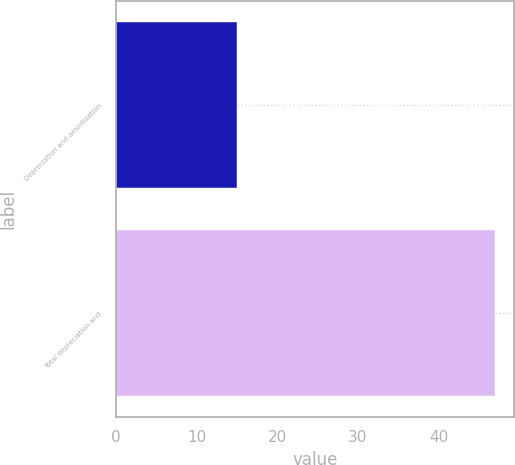Convert chart. <chart><loc_0><loc_0><loc_500><loc_500><bar_chart><fcel>Depreciation and amortization<fcel>Total depreciation and<nl><fcel>15<fcel>47<nl></chart> 